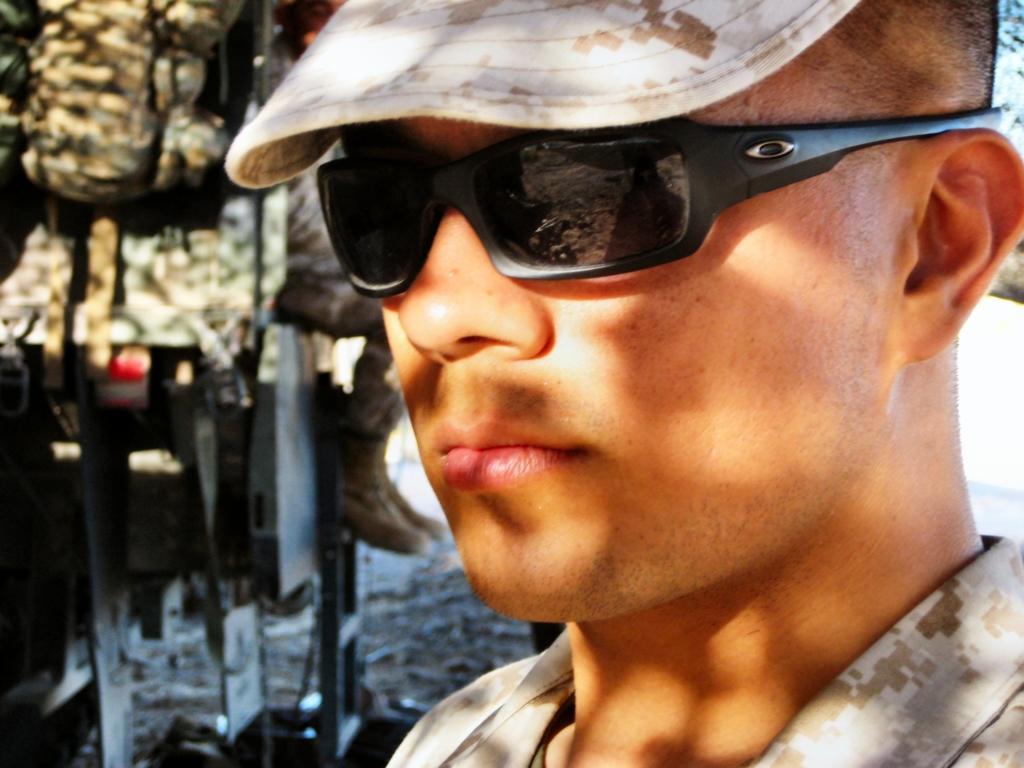Can you describe this image briefly? In this image I can see a person wearing a cap and goggles. 